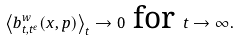<formula> <loc_0><loc_0><loc_500><loc_500>\left \langle b ^ { w } _ { t , t ^ { \epsilon } } { \left ( x , p \right ) } \right \rangle _ { t } \rightarrow 0 \text { for     } t \rightarrow \infty .</formula> 